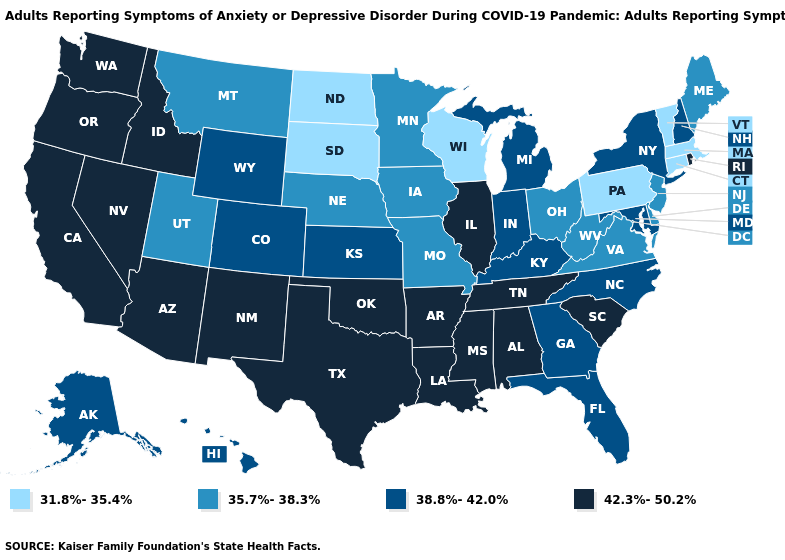Does the map have missing data?
Give a very brief answer. No. Name the states that have a value in the range 31.8%-35.4%?
Write a very short answer. Connecticut, Massachusetts, North Dakota, Pennsylvania, South Dakota, Vermont, Wisconsin. Among the states that border Montana , which have the highest value?
Write a very short answer. Idaho. Does the first symbol in the legend represent the smallest category?
Be succinct. Yes. What is the highest value in states that border California?
Write a very short answer. 42.3%-50.2%. What is the highest value in the Northeast ?
Keep it brief. 42.3%-50.2%. Does New Hampshire have the highest value in the Northeast?
Quick response, please. No. Does the map have missing data?
Be succinct. No. Which states have the lowest value in the Northeast?
Short answer required. Connecticut, Massachusetts, Pennsylvania, Vermont. Does Rhode Island have the highest value in the Northeast?
Keep it brief. Yes. Does Kentucky have the lowest value in the USA?
Short answer required. No. What is the value of New Hampshire?
Answer briefly. 38.8%-42.0%. Name the states that have a value in the range 42.3%-50.2%?
Quick response, please. Alabama, Arizona, Arkansas, California, Idaho, Illinois, Louisiana, Mississippi, Nevada, New Mexico, Oklahoma, Oregon, Rhode Island, South Carolina, Tennessee, Texas, Washington. Does West Virginia have a lower value than Nebraska?
Answer briefly. No. Name the states that have a value in the range 31.8%-35.4%?
Give a very brief answer. Connecticut, Massachusetts, North Dakota, Pennsylvania, South Dakota, Vermont, Wisconsin. 